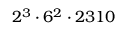Convert formula to latex. <formula><loc_0><loc_0><loc_500><loc_500>2 ^ { 3 } \cdot 6 ^ { 2 } \cdot 2 3 1 0</formula> 